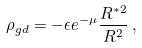<formula> <loc_0><loc_0><loc_500><loc_500>\rho _ { g d } = - \epsilon e ^ { - \mu } \frac { R ^ { * 2 } } { R ^ { 2 } } \, ,</formula> 